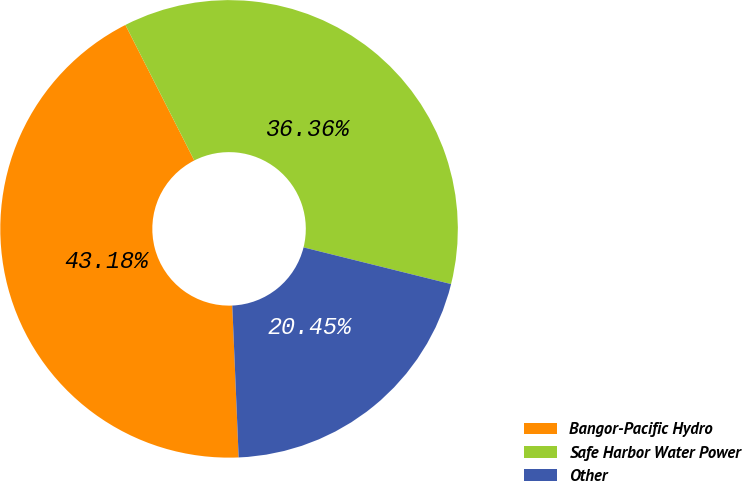Convert chart to OTSL. <chart><loc_0><loc_0><loc_500><loc_500><pie_chart><fcel>Bangor-Pacific Hydro<fcel>Safe Harbor Water Power<fcel>Other<nl><fcel>43.18%<fcel>36.36%<fcel>20.45%<nl></chart> 